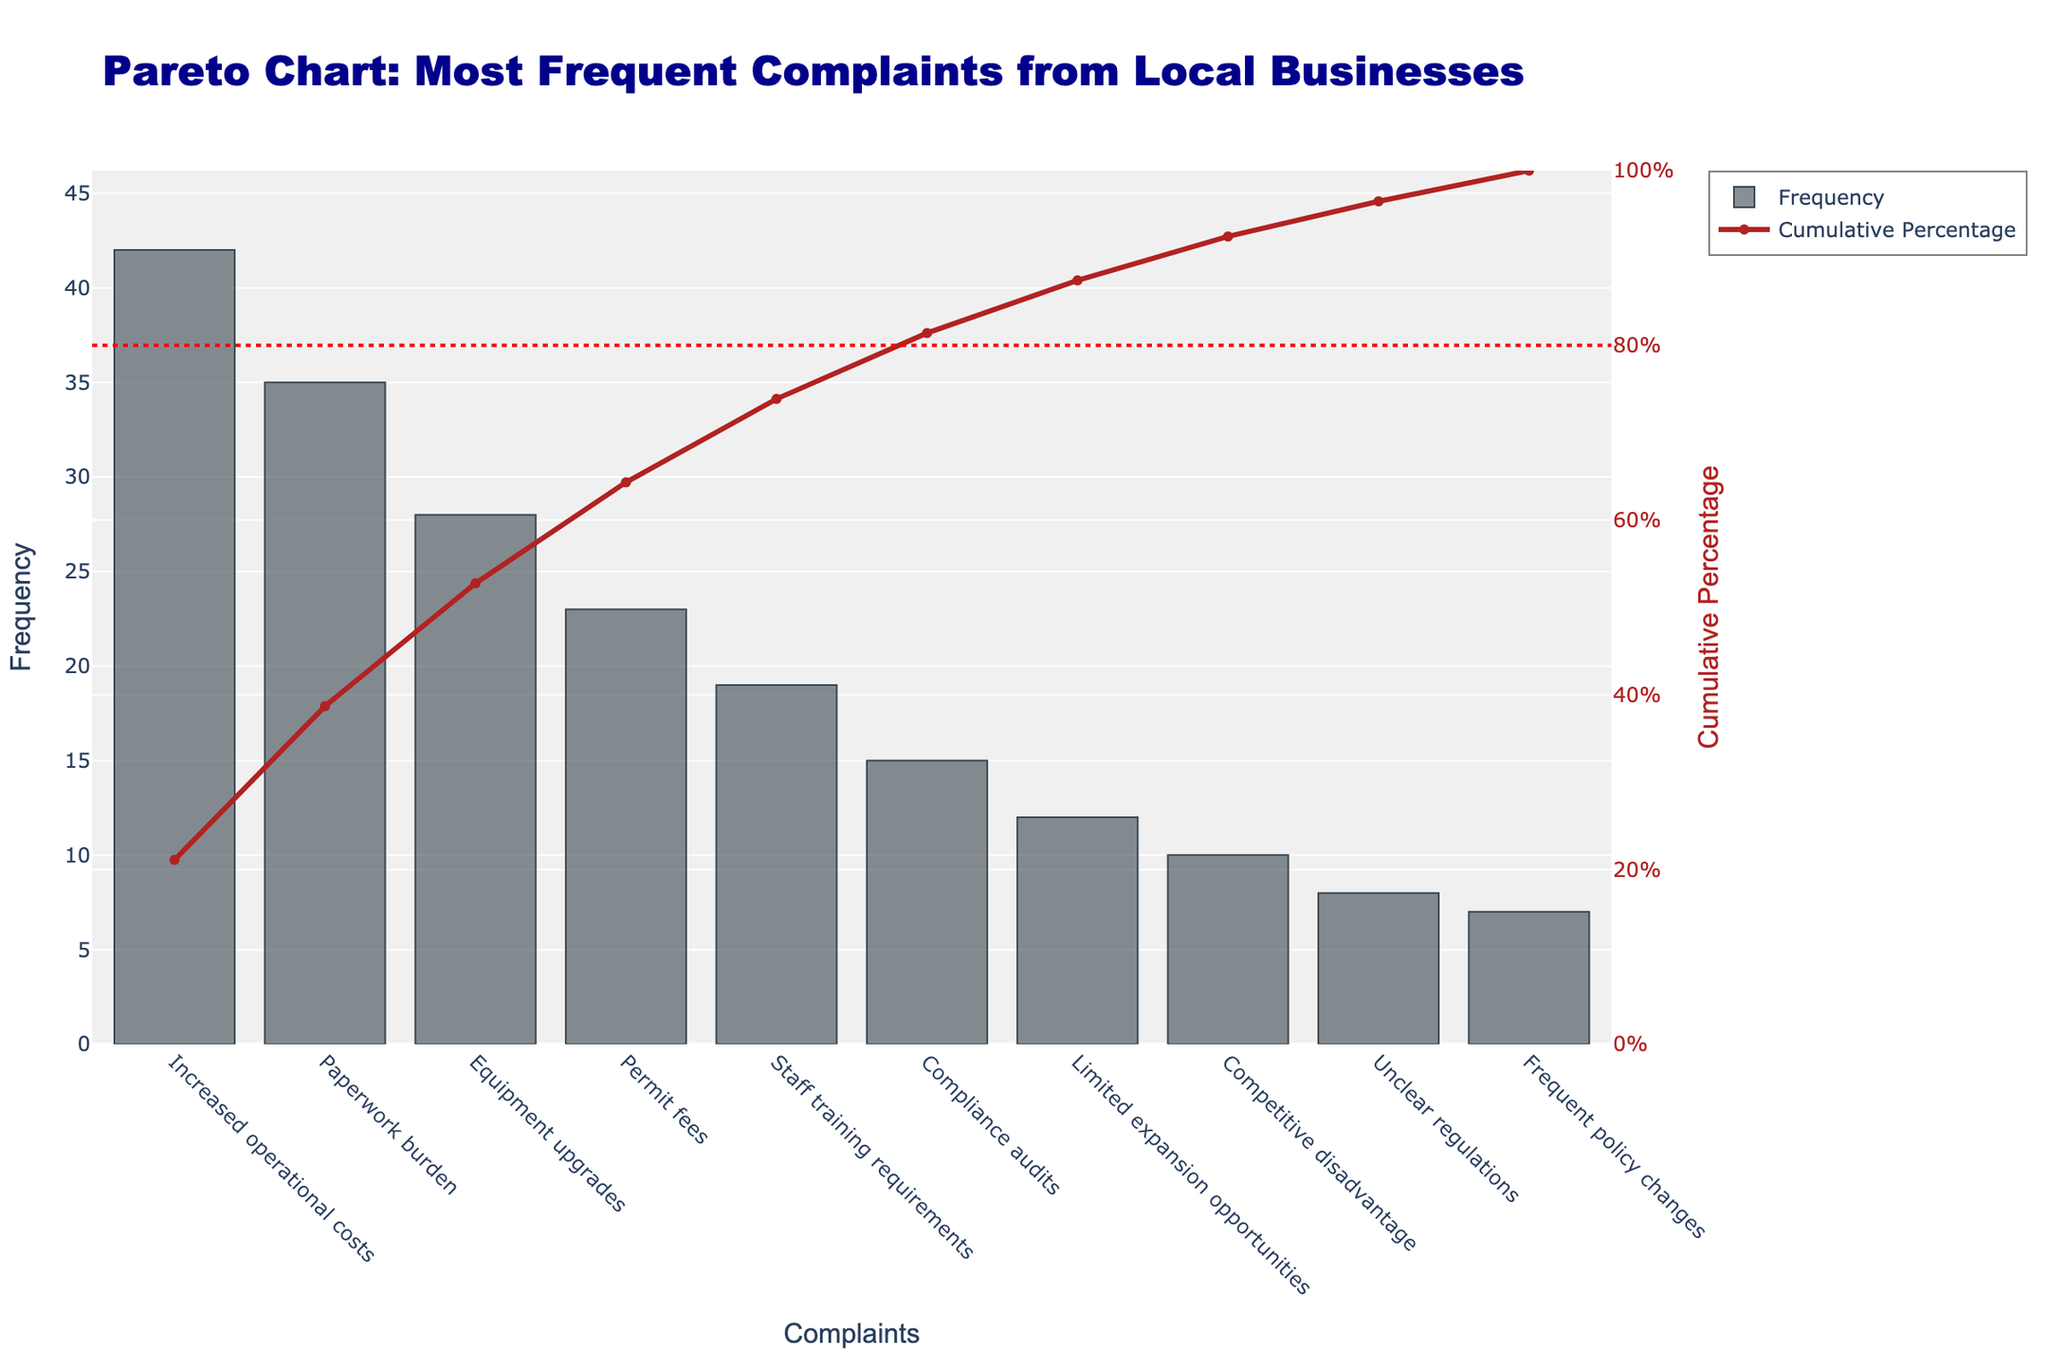What is the title of the chart? The title of the chart is found at the top and it reads "Pareto Chart: Most Frequent Complaints from Local Businesses".
Answer: Pareto Chart: Most Frequent Complaints from Local Businesses Which complaint has the highest frequency? The highest frequency complaint is represented by the tallest bar on the chart. It is labeled "Increased operational costs" with a frequency of 42.
Answer: Increased operational costs What does the secondary y-axis represent? The secondary y-axis, located on the right side of the chart, represents the "Cumulative Percentage" of the complaints.
Answer: Cumulative Percentage How many complaints contribute to 80% of the total frequency? To find how many complaints contribute to 80% of the total frequency, look at the cumulative percentage line and identify where it crosses the 80% horizontal line. This occurs between "Equipment upgrades" and "Permit fees". Therefore, the first four complaints make up 80%.
Answer: 4 complaints Which complaints are below the cumulative 80% line? By observing the cumulative percentage line and the 80% mark, the complaints below the line are "Increased operational costs," "Paperwork burden," "Equipment upgrades," and "Permit fees".
Answer: Increased operational costs, Paperwork burden, Equipment upgrades, Permit fees Is "Staff training requirements" more frequent than "Compliance audits"? Compare the heights of the bars for "Staff training requirements" and "Compliance audits". "Staff training requirements" is higher with a frequency of 19 compared to 15 for "Compliance audits".
Answer: Yes What is the cumulative percentage after five complaints? To find the cumulative percentage after five complaints, look at the cumulative percentage value at the fifth bar labeled "Staff training requirements". The cumulative percentage is approximately 75%.
Answer: 75% Which complaint has the smallest frequency, and what is its cumulative percentage? The smallest frequency complaint is represented by the shortest bar labeled "Frequent policy changes" with a frequency of 7. Its cumulative percentage is around 95%.
Answer: Frequent policy changes, 95% By how much do "Increased operational costs" surpass "Competitive disadvantage" in frequency? "Increased operational costs" have a frequency of 42, and "Competitive disadvantage" has a frequency of 10. The difference is calculated by subtracting the frequency of "Competitive disadvantage" from that of "Increased operational costs": 42 - 10 = 32.
Answer: 32 